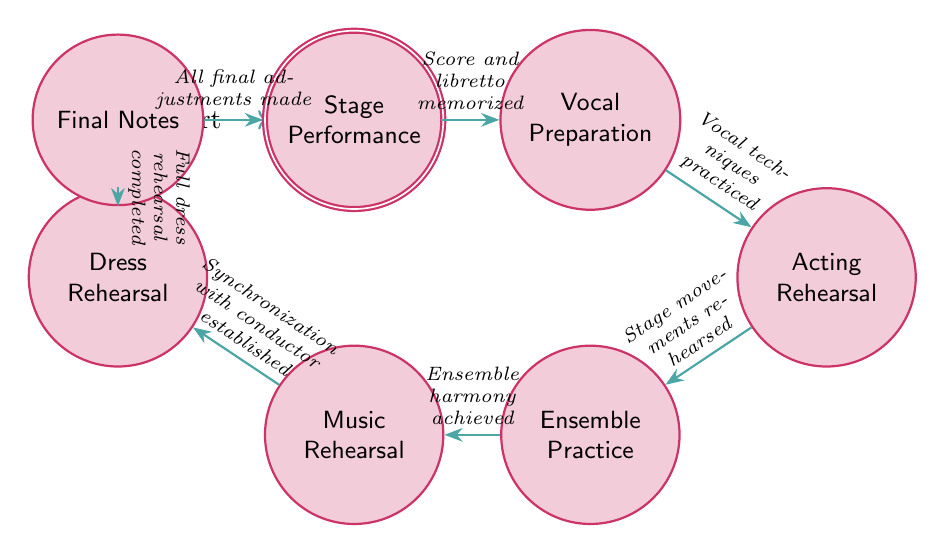What is the initial state of the rehearsal process? The diagram indicates that the initial state is labeled as "Score Learning," representing the starting point of the rehearsal process where the score and libretto are learned and memorized.
Answer: Score Learning How many states are present in the rehearsal diagram? By counting each distinct state node in the diagram, there are a total of eight states listed, each representing a step in the opera rehearsal process.
Answer: Eight What is the condition to move from Vocal Preparation to Acting Rehearsal? The transition from "Vocal Preparation" to "Acting Rehearsal" requires the condition of having practiced vocal techniques, which must be satisfied before the change can occur.
Answer: Vocal techniques practiced Which state comes after Ensemble Practice? Following the state labeled "Ensemble Practice," the next state is "Music Rehearsal With Conductor," indicating the sequence that follows achieving harmony with other members.
Answer: Music Rehearsal With Conductor What happens after Final Notes? Once all final adjustments are made and the conditions of "Final Notes" are satisfied, the next step in the process is to proceed to "Stage Performance," culminating in the actual public performance.
Answer: Stage Performance What is the relationship between Acting Rehearsal and Ensemble Practice? The relationship between these two states is that "Acting Rehearsal" must reach a state where stage movements are rehearsed before transitioning to "Ensemble Practice." Thus, the prerequisite condition links them sequentially.
Answer: Stage movements rehearsed What is the last state before the Stage Performance? The state immediately preceding "Stage Performance" is "Final Notes," representing the final tuning stage before the performance begins.
Answer: Final Notes What condition must be met to transition to Dress Rehearsal? To move from "Music Rehearsal With Conductor" to "Dress Rehearsal," it is necessary to establish synchronization with the conductor as the condition for the transition.
Answer: Synchronization with conductor established 